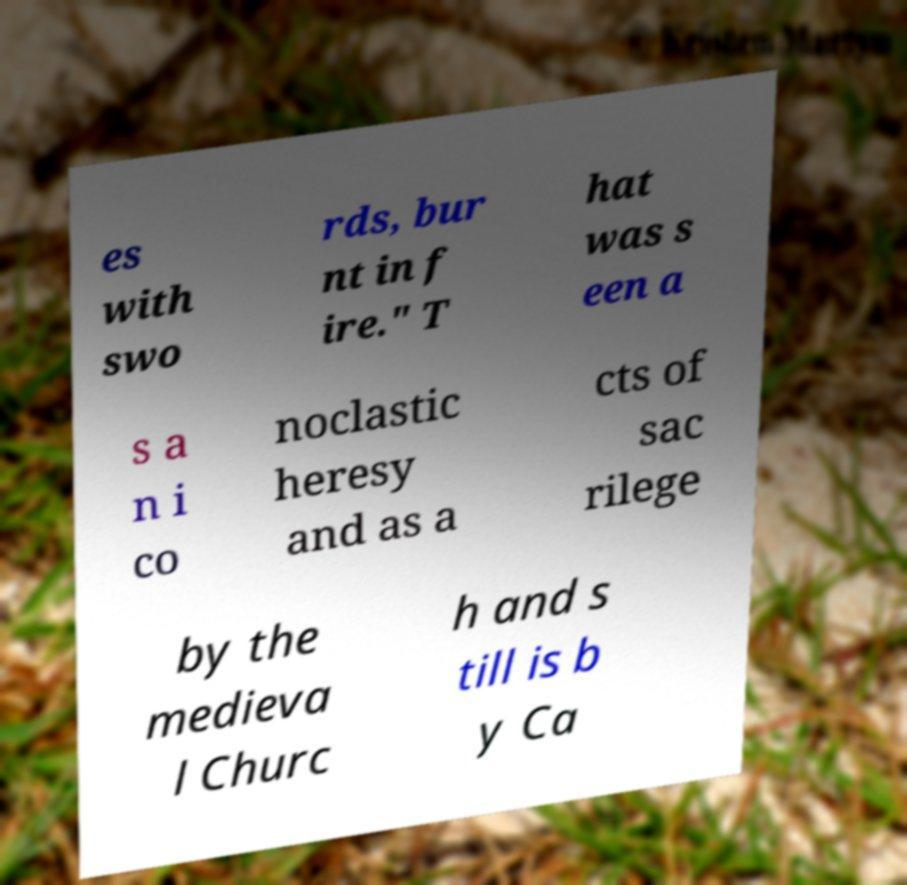Can you read and provide the text displayed in the image?This photo seems to have some interesting text. Can you extract and type it out for me? es with swo rds, bur nt in f ire." T hat was s een a s a n i co noclastic heresy and as a cts of sac rilege by the medieva l Churc h and s till is b y Ca 